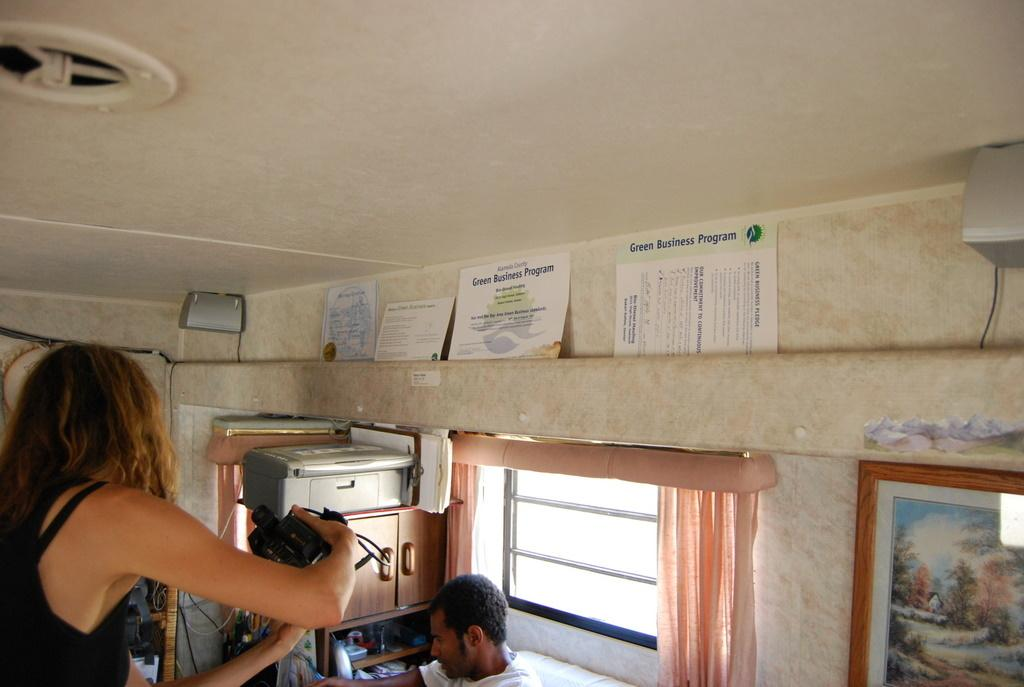<image>
Summarize the visual content of the image. A man and woman work in a certified Green Business Program. 